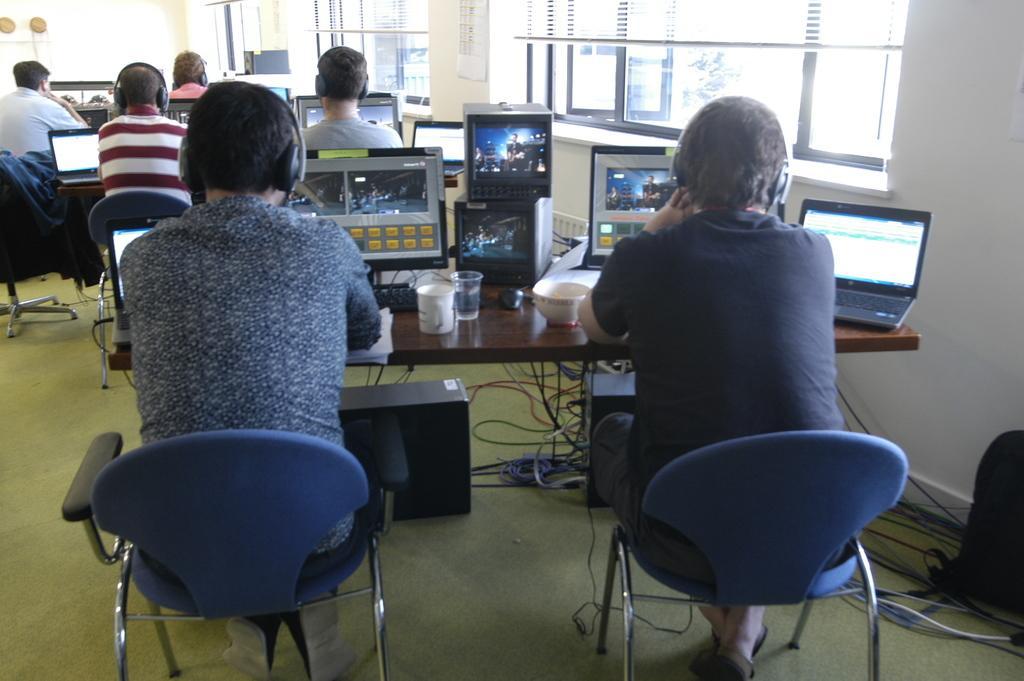Describe this image in one or two sentences. in this Picture we can see a group of people sitting in the office and watching the video on the computer screen. On the right side we can see a person with blue color t- shirt with headphone watching the video in the screen , at the left corner laptop is placed and on the right side a cup and water glasses is seen. On the right side of the wall big window and trees can be seen. 